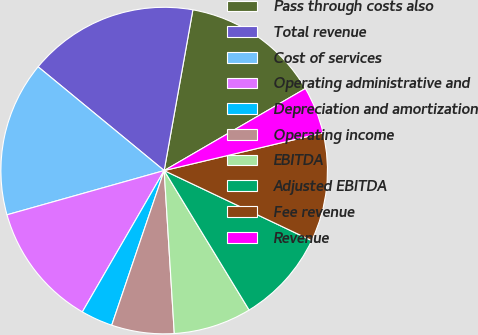Convert chart. <chart><loc_0><loc_0><loc_500><loc_500><pie_chart><fcel>Pass through costs also<fcel>Total revenue<fcel>Cost of services<fcel>Operating administrative and<fcel>Depreciation and amortization<fcel>Operating income<fcel>EBITDA<fcel>Adjusted EBITDA<fcel>Fee revenue<fcel>Revenue<nl><fcel>13.81%<fcel>16.85%<fcel>15.33%<fcel>12.28%<fcel>3.15%<fcel>6.19%<fcel>7.72%<fcel>9.24%<fcel>10.76%<fcel>4.67%<nl></chart> 